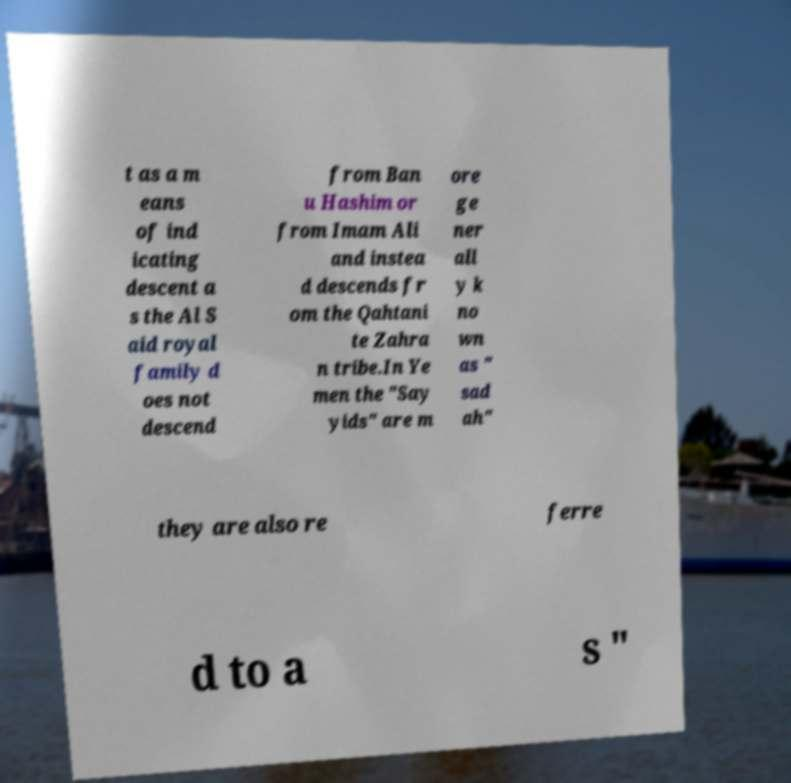Could you assist in decoding the text presented in this image and type it out clearly? t as a m eans of ind icating descent a s the Al S aid royal family d oes not descend from Ban u Hashim or from Imam Ali and instea d descends fr om the Qahtani te Zahra n tribe.In Ye men the "Say yids" are m ore ge ner all y k no wn as " sad ah" they are also re ferre d to a s " 